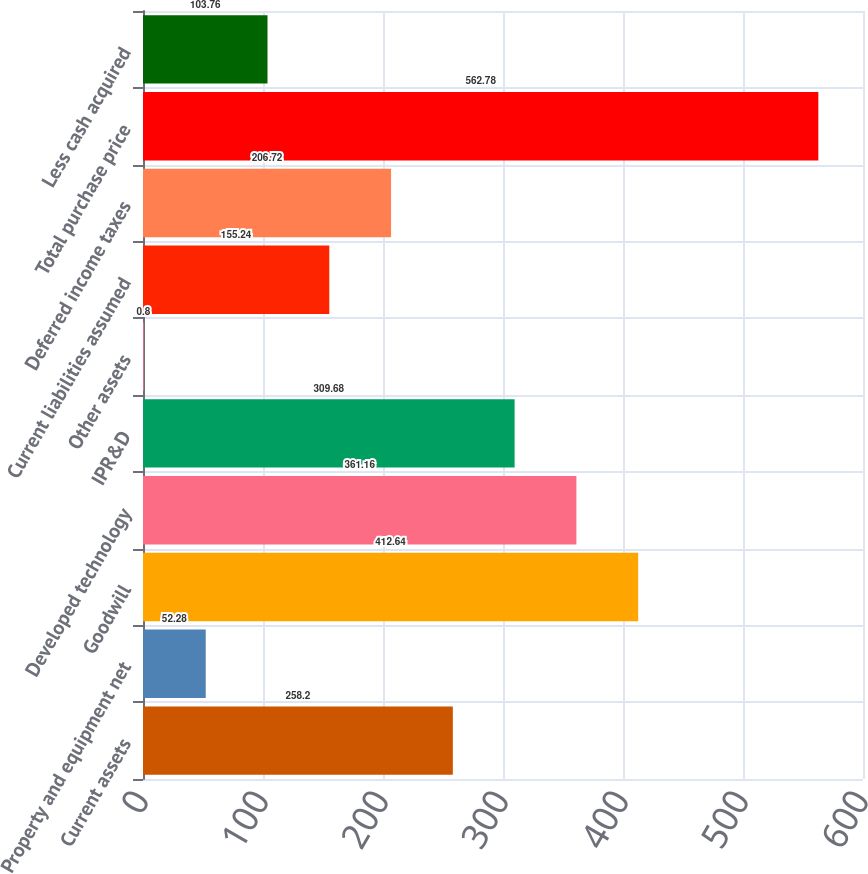Convert chart to OTSL. <chart><loc_0><loc_0><loc_500><loc_500><bar_chart><fcel>Current assets<fcel>Property and equipment net<fcel>Goodwill<fcel>Developed technology<fcel>IPR&D<fcel>Other assets<fcel>Current liabilities assumed<fcel>Deferred income taxes<fcel>Total purchase price<fcel>Less cash acquired<nl><fcel>258.2<fcel>52.28<fcel>412.64<fcel>361.16<fcel>309.68<fcel>0.8<fcel>155.24<fcel>206.72<fcel>562.78<fcel>103.76<nl></chart> 